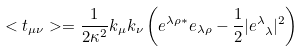Convert formula to latex. <formula><loc_0><loc_0><loc_500><loc_500>< t _ { \mu \nu } > = \frac { 1 } { 2 \kappa ^ { 2 } } k _ { \mu } k _ { \nu } \left ( e ^ { \lambda \rho * } e _ { \lambda \rho } - \frac { 1 } { 2 } | e ^ { \lambda } _ { \ \lambda } | ^ { 2 } \right )</formula> 